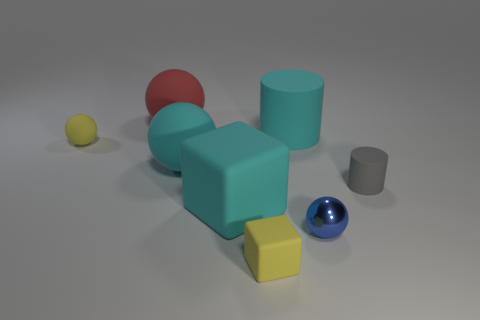There is a yellow matte object that is to the right of the small yellow rubber object that is behind the small metallic sphere; what is its size? small 